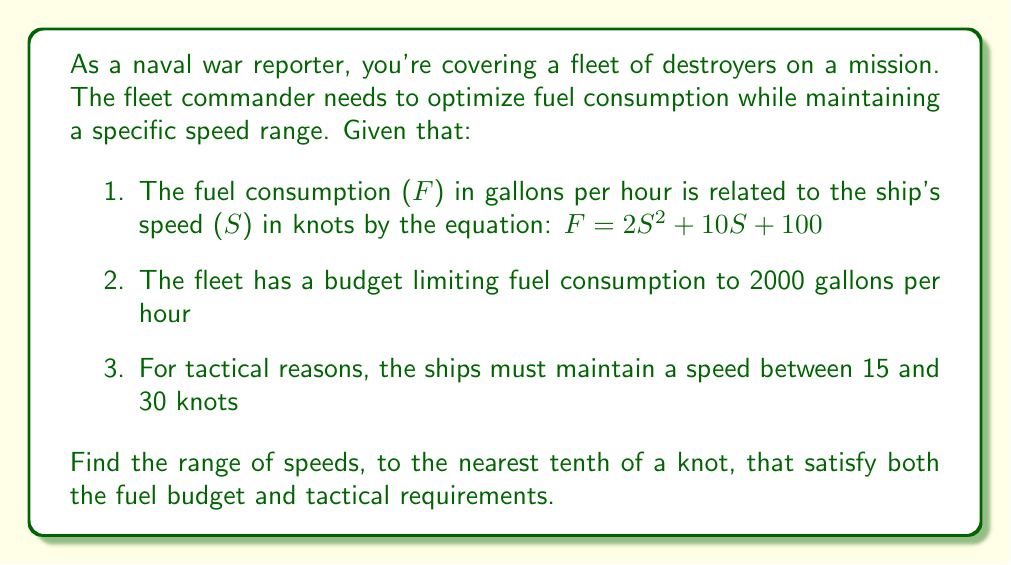Solve this math problem. To solve this problem, we need to set up and solve an inequality based on the given information:

1. The fuel consumption equation: $F = 2S^2 + 10S + 100$
2. The fuel budget constraint: $F \leq 2000$
3. The tactical speed range: $15 \leq S \leq 30$

Combining these, we get the compound inequality:

$15 \leq S \leq 30$ and $2S^2 + 10S + 100 \leq 2000$

Let's focus on solving the quadratic inequality:

$2S^2 + 10S + 100 \leq 2000$
$2S^2 + 10S - 1900 \leq 0$

To solve this, we need to find the roots of the quadratic equation:
$2S^2 + 10S - 1900 = 0$

Using the quadratic formula, $S = \frac{-b \pm \sqrt{b^2 - 4ac}}{2a}$, we get:

$S = \frac{-10 \pm \sqrt{100 + 15200}}{4} = \frac{-10 \pm \sqrt{15300}}{4}$

$S \approx 29.9$ or $S \approx -31.7$

Since speed cannot be negative, we only consider the positive root. The inequality is satisfied when $S \leq 29.9$.

Combining this with the tactical speed range:

$15 \leq S \leq 29.9$

Rounding to the nearest tenth of a knot:

$15.0 \leq S \leq 29.9$
Answer: The range of speeds that satisfy both the fuel budget and tactical requirements is 15.0 to 29.9 knots. 